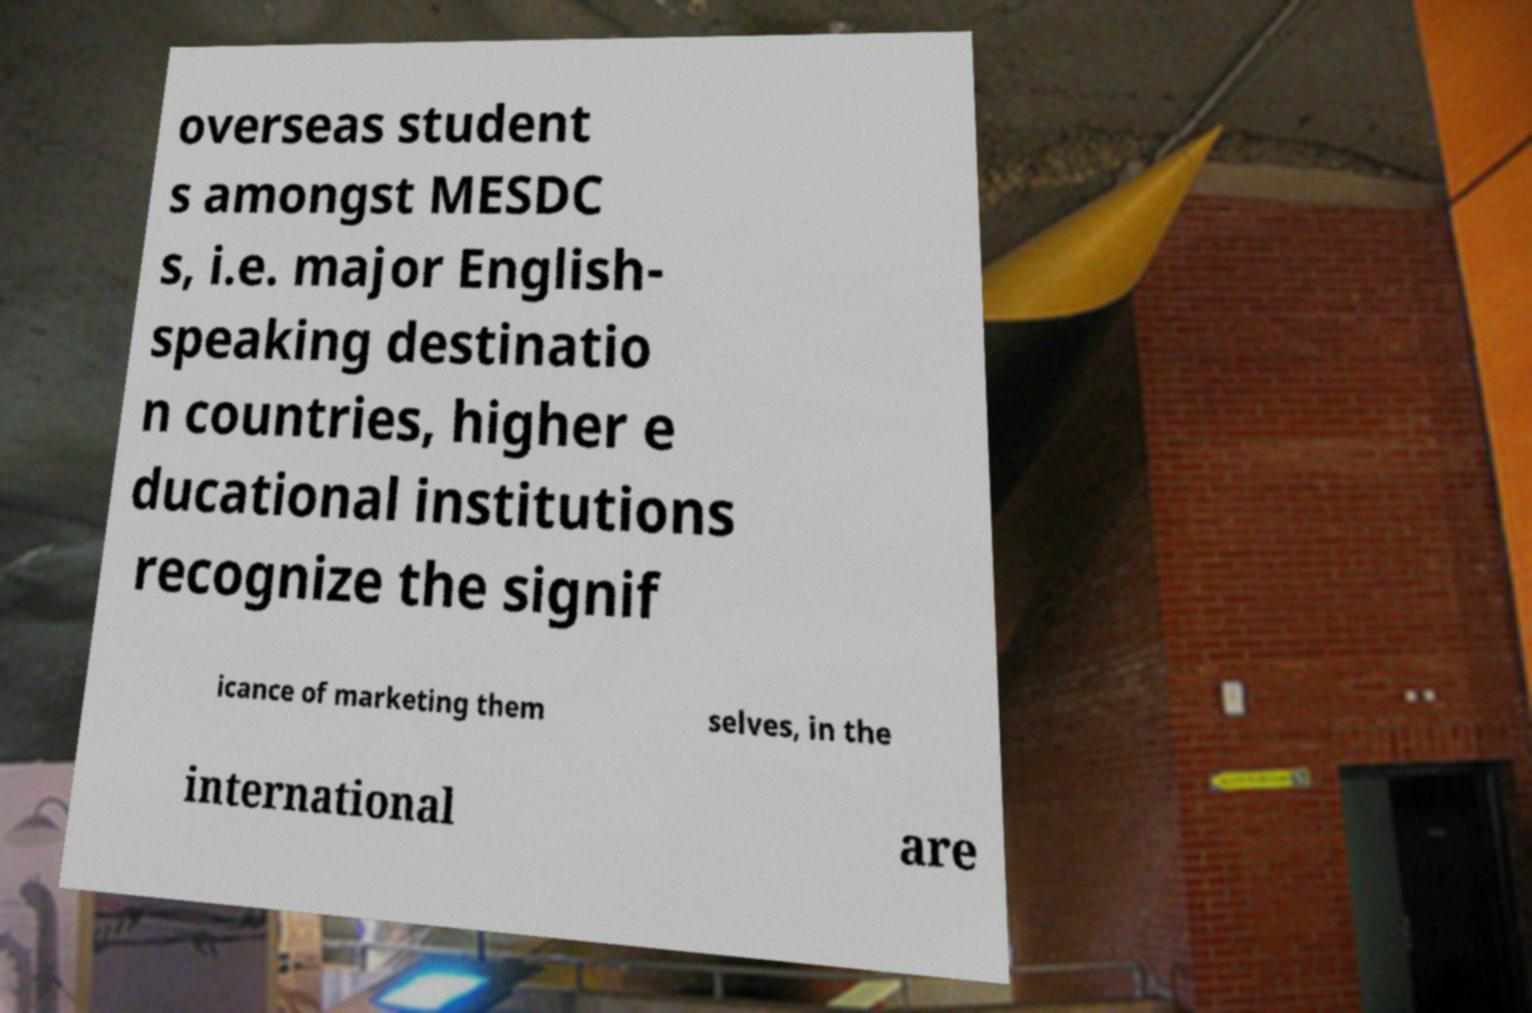Can you read and provide the text displayed in the image?This photo seems to have some interesting text. Can you extract and type it out for me? overseas student s amongst MESDC s, i.e. major English- speaking destinatio n countries, higher e ducational institutions recognize the signif icance of marketing them selves, in the international are 